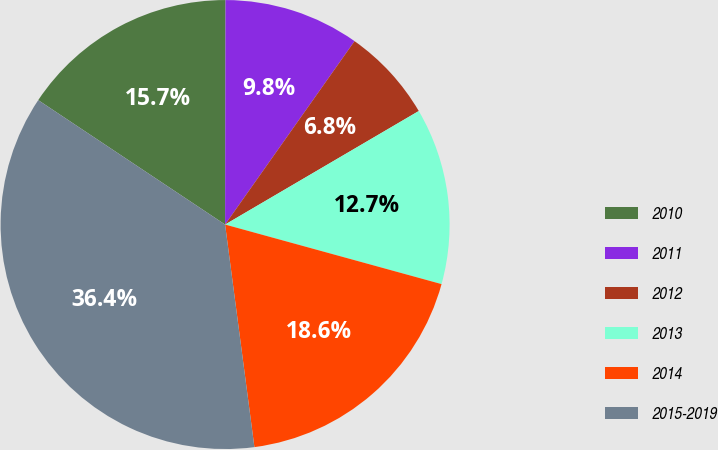Convert chart to OTSL. <chart><loc_0><loc_0><loc_500><loc_500><pie_chart><fcel>2010<fcel>2011<fcel>2012<fcel>2013<fcel>2014<fcel>2015-2019<nl><fcel>15.68%<fcel>9.75%<fcel>6.78%<fcel>12.71%<fcel>18.64%<fcel>36.43%<nl></chart> 